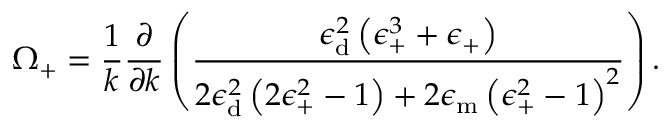Convert formula to latex. <formula><loc_0><loc_0><loc_500><loc_500>\Omega _ { + } = \frac { 1 } { k } \frac { \partial } { \partial k } \left ( \frac { \epsilon _ { d } ^ { 2 } \left ( \epsilon _ { + } ^ { 3 } + \epsilon _ { + } \right ) } { 2 \epsilon _ { d } ^ { 2 } \left ( 2 \epsilon _ { + } ^ { 2 } - 1 \right ) + 2 \epsilon _ { m } \left ( \epsilon _ { + } ^ { 2 } - 1 \right ) ^ { 2 } } \right ) .</formula> 